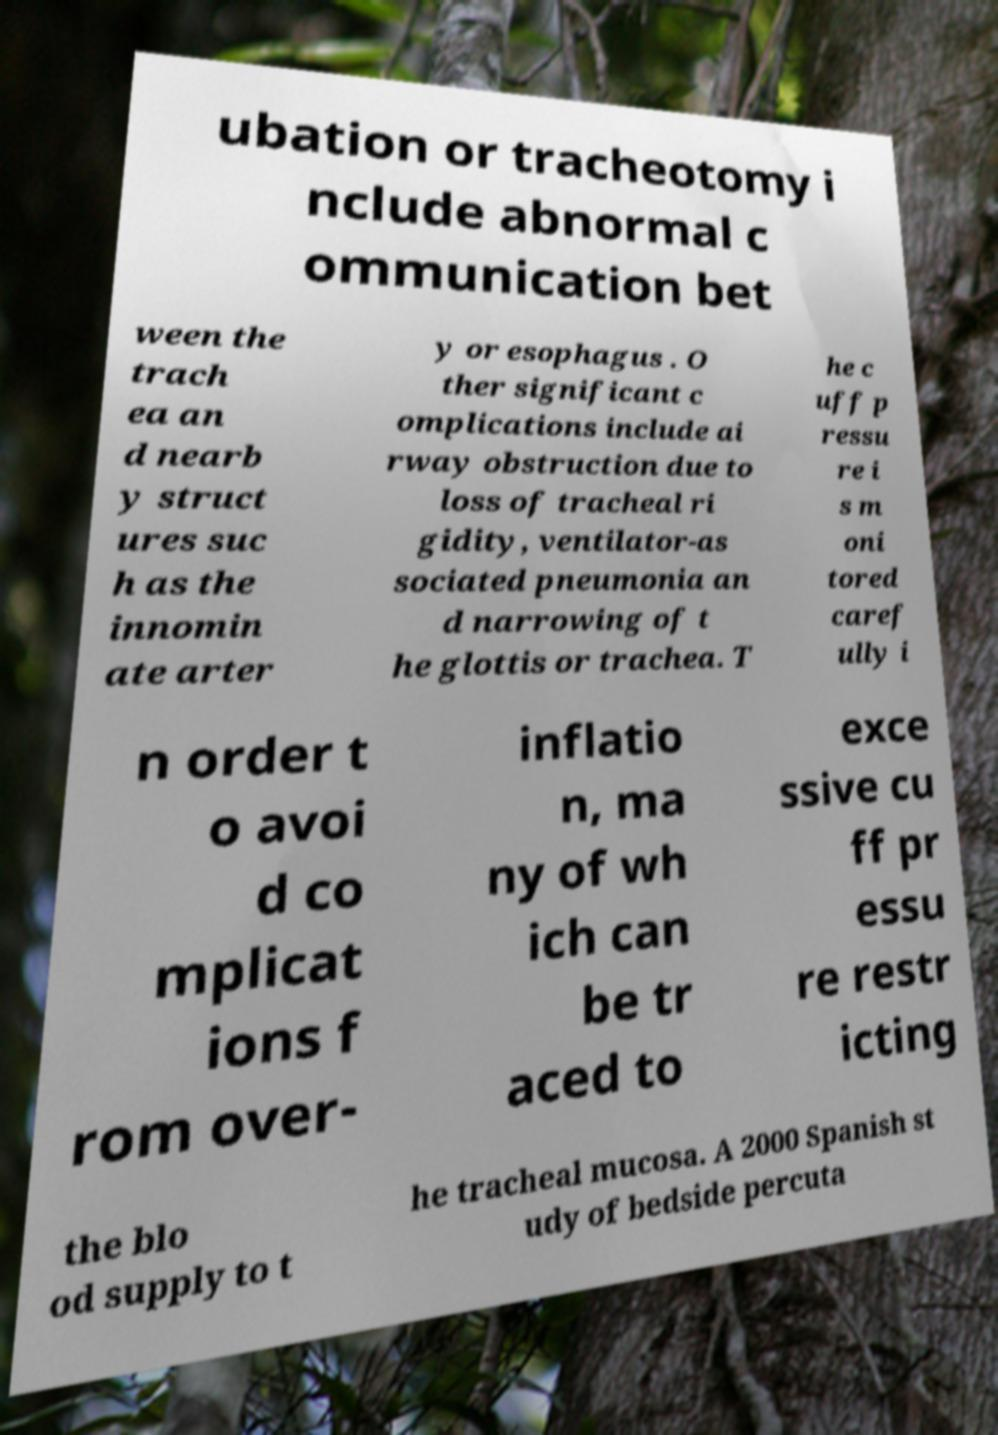For documentation purposes, I need the text within this image transcribed. Could you provide that? ubation or tracheotomy i nclude abnormal c ommunication bet ween the trach ea an d nearb y struct ures suc h as the innomin ate arter y or esophagus . O ther significant c omplications include ai rway obstruction due to loss of tracheal ri gidity, ventilator-as sociated pneumonia an d narrowing of t he glottis or trachea. T he c uff p ressu re i s m oni tored caref ully i n order t o avoi d co mplicat ions f rom over- inflatio n, ma ny of wh ich can be tr aced to exce ssive cu ff pr essu re restr icting the blo od supply to t he tracheal mucosa. A 2000 Spanish st udy of bedside percuta 